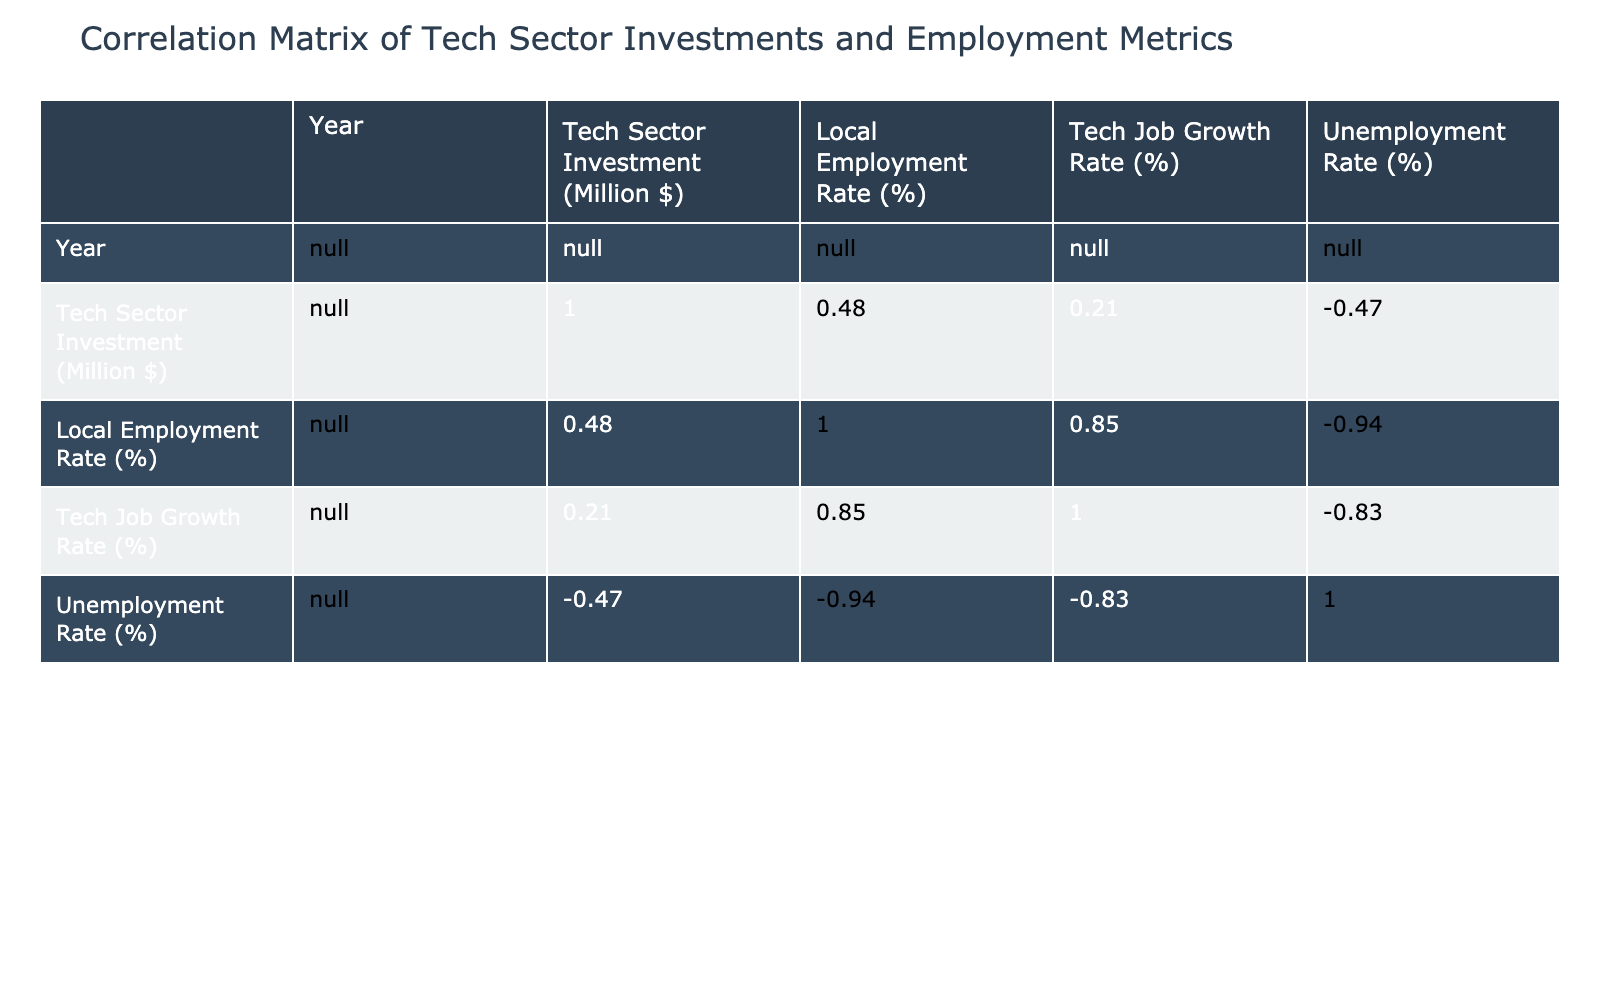What city has the highest Tech Sector Investment in 2022? According to the table, the city with the highest Tech Sector Investment in 2022 is New York City, with an investment of 20,000 million dollars.
Answer: New York City What is the Local Employment Rate in San Francisco in 2022? The table shows that the Local Employment Rate in San Francisco in 2022 is 94.5%.
Answer: 94.5% What is the difference between the Tech Sector Investment of Austin and Detroit? From the table, Austin's Tech Sector Investment is 5,000 million dollars, while Detroit's is 2,000 million dollars. The difference is 5,000 - 2,000 = 3,000 million dollars.
Answer: 3,000 million dollars What is the average Local Employment Rate for Chicago, Miami, and Los Angeles? The Local Employment Rates for Chicago, Miami, and Los Angeles are 89.0%, 87.5%, and 88.0%, respectively. The average is (89.0 + 87.5 + 88.0) / 3 = 88.17%.
Answer: 88.17% Is the Tech Job Growth Rate in Seattle higher than that in Detroit? According to the table, Seattle's Tech Job Growth Rate is 10.5% while Detroit's is 5.0%. Since 10.5% is greater than 5.0%, the statement is true.
Answer: Yes What is the relationship between Tech Sector Investment and Unemployment Rate based on the table? To analyze the relationship, we can look at the trend: cities with higher Tech Sector Investments tend to have lower Unemployment Rates. For instance, San Francisco has the highest investment (15,000 million) and a low unemployment rate (3.5%). Detroit, on the other hand, has the lowest investment (2,000 million) and the highest unemployment rate (6.0%). Thus, there is a negative correlation.
Answer: Negative correlation Which city has the lowest Local Employment Rate and what is that rate? The table shows that Detroit has the lowest Local Employment Rate at 85.0%.
Answer: Detroit, 85.0% If we add the Tech Job Growth Rates of all cities, what would be the total? The Tech Job Growth Rates for the cities are 12.0%, 18.0%, 10.5%, 11.0%, 9.5%, 8.0%, 15.0%, 20.0%, 5.0%, and 7.0%. Summing these rates results in 12.0 + 18.0 + 10.5 + 11.0 + 9.5 + 8.0 + 15.0 + 20.0 + 5.0 + 7.0 = 106.0%.
Answer: 106.0% 